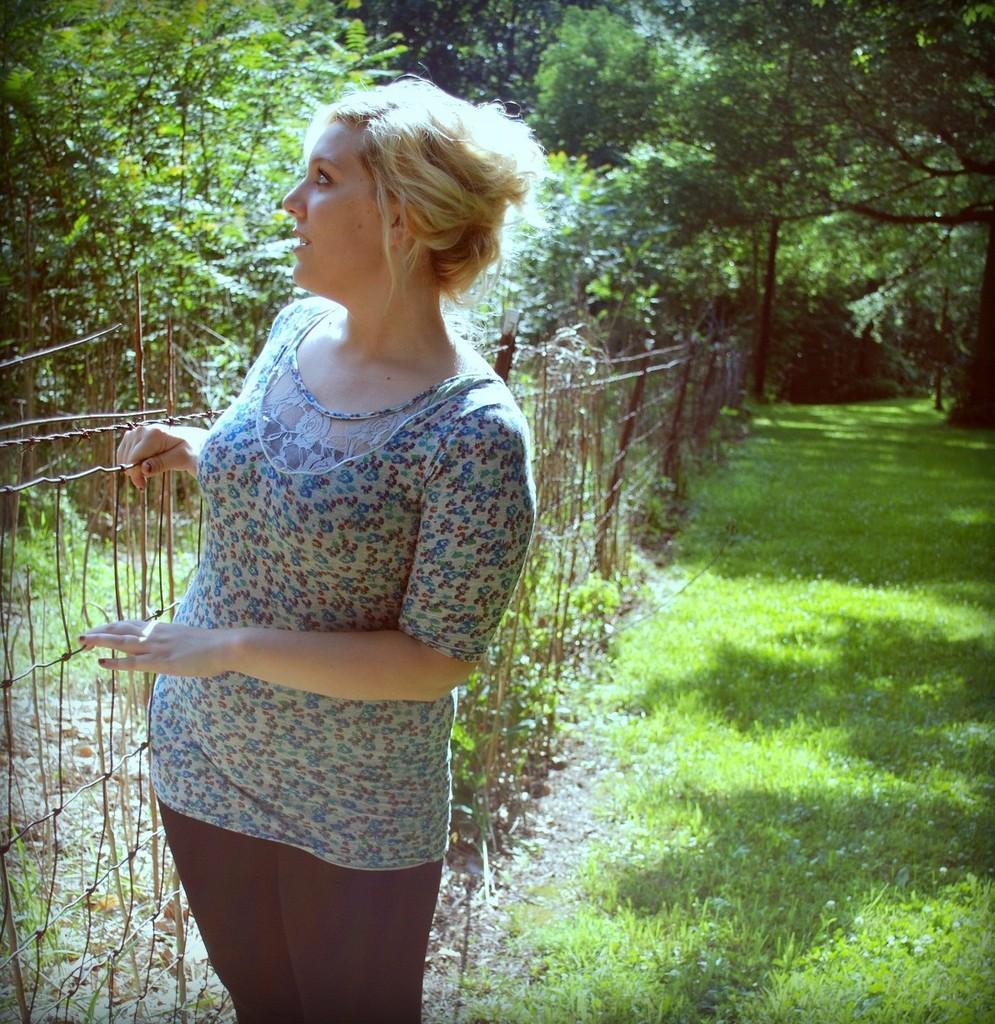Could you give a brief overview of what you see in this image? In this picture we can see a woman and in the background we can see a fence, grass, trees. 